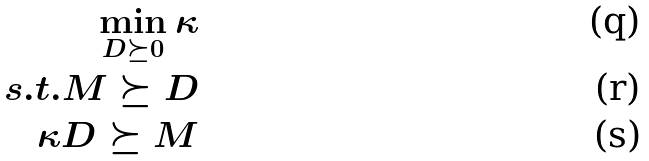Convert formula to latex. <formula><loc_0><loc_0><loc_500><loc_500>\min _ { D \succeq 0 } \kappa \\ s . t . M \succeq D \\ \kappa D \succeq M</formula> 